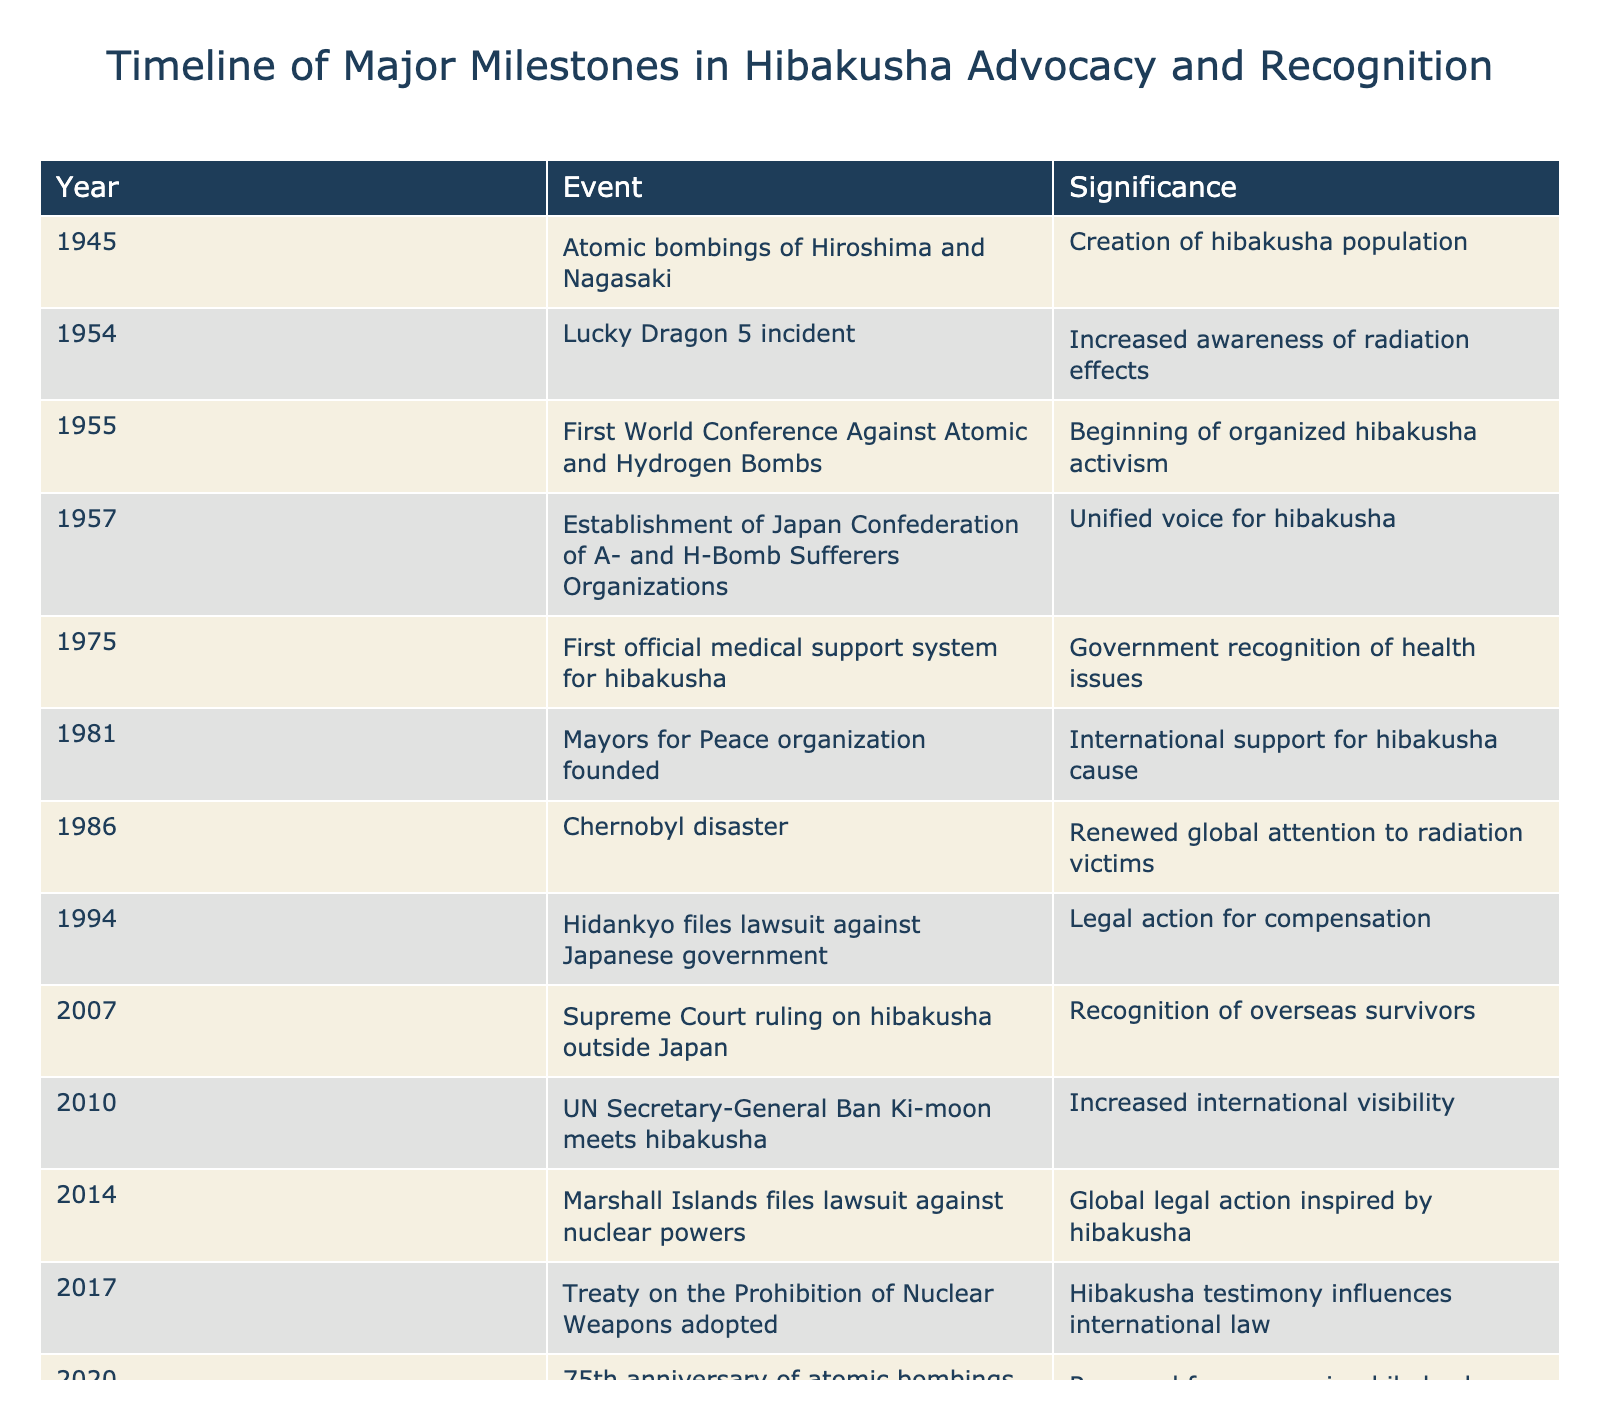What year did the atomic bombings of Hiroshima and Nagasaki occur? The table shows that the atomic bombings happened in 1945, which is clearly stated in the year column.
Answer: 1945 What significant event related to hibakusha advocacy occurred in 1981? According to the table, the Mayors for Peace organization was founded in 1981, as indicated in the event column.
Answer: Mayors for Peace organization founded How many years are between the establishment of the Japan Confederation of A- and H-Bomb Sufferers Organizations and the first official medical support system for hibakusha? The establishment of the organization was in 1957 and the medical support system was in 1975. Calculating the difference gives us 1975 - 1957 = 18 years.
Answer: 18 years True or False: The Chernobyl disaster occurred after the establishment of the Japan Confederation of A- and H-Bomb Sufferers Organizations. The table indicates that the confederation was established in 1957 and the Chernobyl disaster took place in 1986, meaning the statement is true.
Answer: True In which event did the UN Secretary-General Ban Ki-moon meet hibakusha? The table records that Ban Ki-moon met hibakusha in 2010, as noted in the event description.
Answer: 2010 What is the total number of significant events listed in the table? There are a total of 15 events listed in the table. This is determined by counting each entry from 1945 to 2021.
Answer: 15 events How many events lead to increased international visibility of hibakusha? Looking at the table, the events that contribute to international visibility are the founding of the Mayors for Peace organization (1981), the meeting with Ban Ki-moon (2010), and the adoption of the Treaty on the Prohibition of Nuclear Weapons (2017). That's a total of 3 events.
Answer: 3 events What event marked the culmination of decades of hibakusha advocacy? The table states that the Treaty on the Prohibition of Nuclear Weapons entered into force in 2021, marking this significant culmination.
Answer: Treaty on the Prohibition of Nuclear Weapons enters into force Which event occurred first, the Lucky Dragon 5 incident or the first World Conference Against Atomic and Hydrogen Bombs? According to the table, the Lucky Dragon 5 incident happened in 1954, and the first conference was in 1955, so the Lucky Dragon incident occurred first.
Answer: Lucky Dragon 5 incident What was the significance of the 1975 event in relation to government recognition? The table specifies that in 1975, the first official medical support system for hibakusha was established, reflecting a recognition of their health issues by the government.
Answer: Government recognition of health issues 